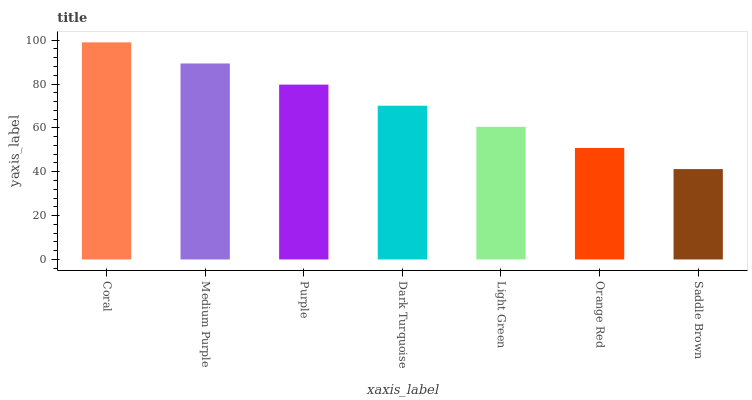Is Saddle Brown the minimum?
Answer yes or no. Yes. Is Coral the maximum?
Answer yes or no. Yes. Is Medium Purple the minimum?
Answer yes or no. No. Is Medium Purple the maximum?
Answer yes or no. No. Is Coral greater than Medium Purple?
Answer yes or no. Yes. Is Medium Purple less than Coral?
Answer yes or no. Yes. Is Medium Purple greater than Coral?
Answer yes or no. No. Is Coral less than Medium Purple?
Answer yes or no. No. Is Dark Turquoise the high median?
Answer yes or no. Yes. Is Dark Turquoise the low median?
Answer yes or no. Yes. Is Light Green the high median?
Answer yes or no. No. Is Medium Purple the low median?
Answer yes or no. No. 